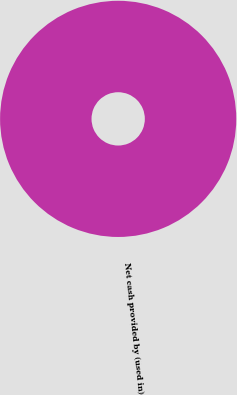Convert chart. <chart><loc_0><loc_0><loc_500><loc_500><pie_chart><fcel>Net cash provided by (used in)<nl><fcel>100.0%<nl></chart> 